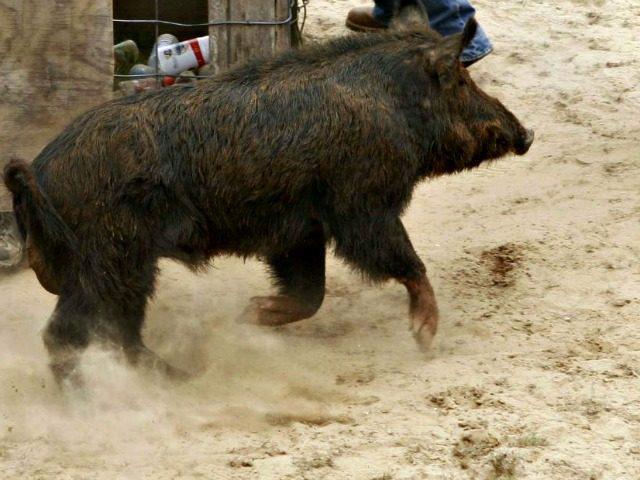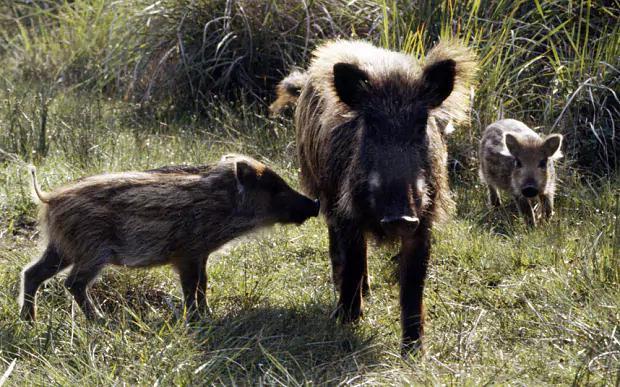The first image is the image on the left, the second image is the image on the right. Evaluate the accuracy of this statement regarding the images: "Right image shows young and adult hogs.". Is it true? Answer yes or no. Yes. The first image is the image on the left, the second image is the image on the right. For the images displayed, is the sentence "There are at least two baby boars in the image on the right" factually correct? Answer yes or no. Yes. 